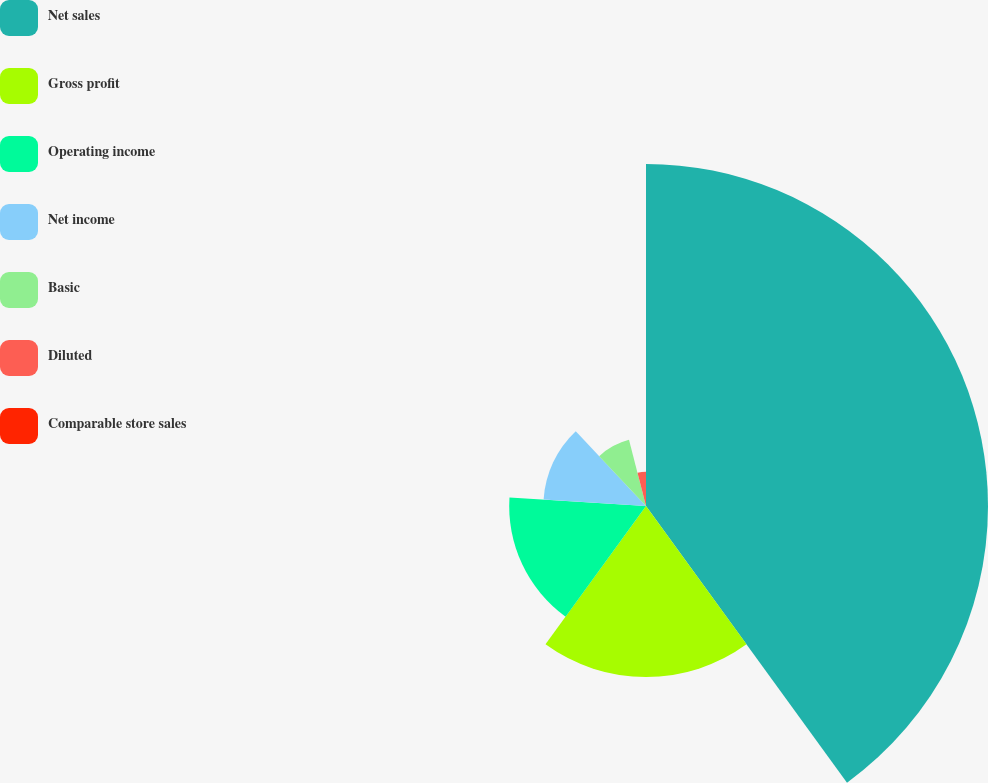Convert chart. <chart><loc_0><loc_0><loc_500><loc_500><pie_chart><fcel>Net sales<fcel>Gross profit<fcel>Operating income<fcel>Net income<fcel>Basic<fcel>Diluted<fcel>Comparable store sales<nl><fcel>40.0%<fcel>20.0%<fcel>16.0%<fcel>12.0%<fcel>8.0%<fcel>4.0%<fcel>0.0%<nl></chart> 